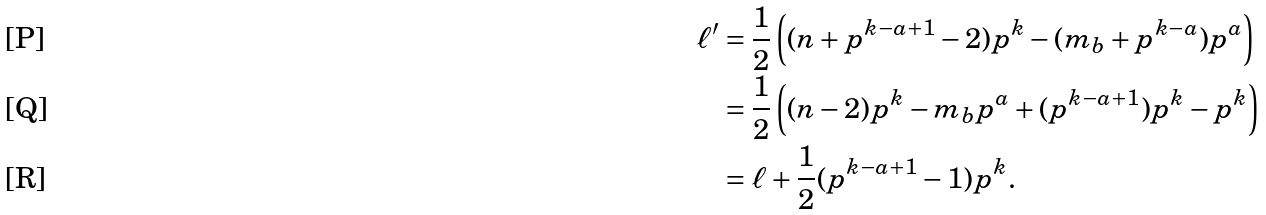<formula> <loc_0><loc_0><loc_500><loc_500>\ell ^ { \prime } & = \frac { 1 } { 2 } \left ( ( n + p ^ { k - a + 1 } - 2 ) p ^ { k } - ( m _ { b } + p ^ { k - a } ) p ^ { a } \right ) \\ & = \frac { 1 } { 2 } \left ( ( n - 2 ) p ^ { k } - m _ { b } p ^ { a } + ( p ^ { k - a + 1 } ) p ^ { k } - p ^ { k } \right ) \\ & = \ell + \frac { 1 } { 2 } ( p ^ { k - a + 1 } - 1 ) p ^ { k } .</formula> 